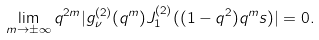Convert formula to latex. <formula><loc_0><loc_0><loc_500><loc_500>\lim _ { m \to \pm \infty } q ^ { 2 m } | g _ { \nu } ^ { ( 2 ) } ( q ^ { m } ) J _ { 1 } ^ { ( 2 ) } ( ( 1 - q ^ { 2 } ) q ^ { m } s ) | = 0 .</formula> 